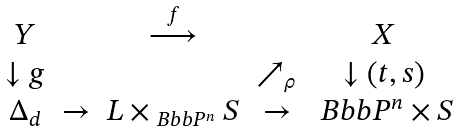Convert formula to latex. <formula><loc_0><loc_0><loc_500><loc_500>\begin{array} { c c c c c } Y & & \overset { f } { \longrightarrow } & & X \\ \downarrow g & & & \nearrow _ { \rho } & \downarrow \left ( t , s \right ) \\ \Delta _ { d } & \rightarrow & L \times _ { \ B b b { P } ^ { n } } S & \rightarrow & \ B b b { P } ^ { n } \times S \end{array}</formula> 